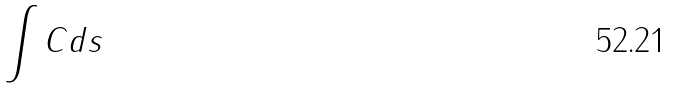Convert formula to latex. <formula><loc_0><loc_0><loc_500><loc_500>\int C d s</formula> 